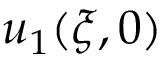<formula> <loc_0><loc_0><loc_500><loc_500>u _ { 1 } ( \xi , 0 )</formula> 